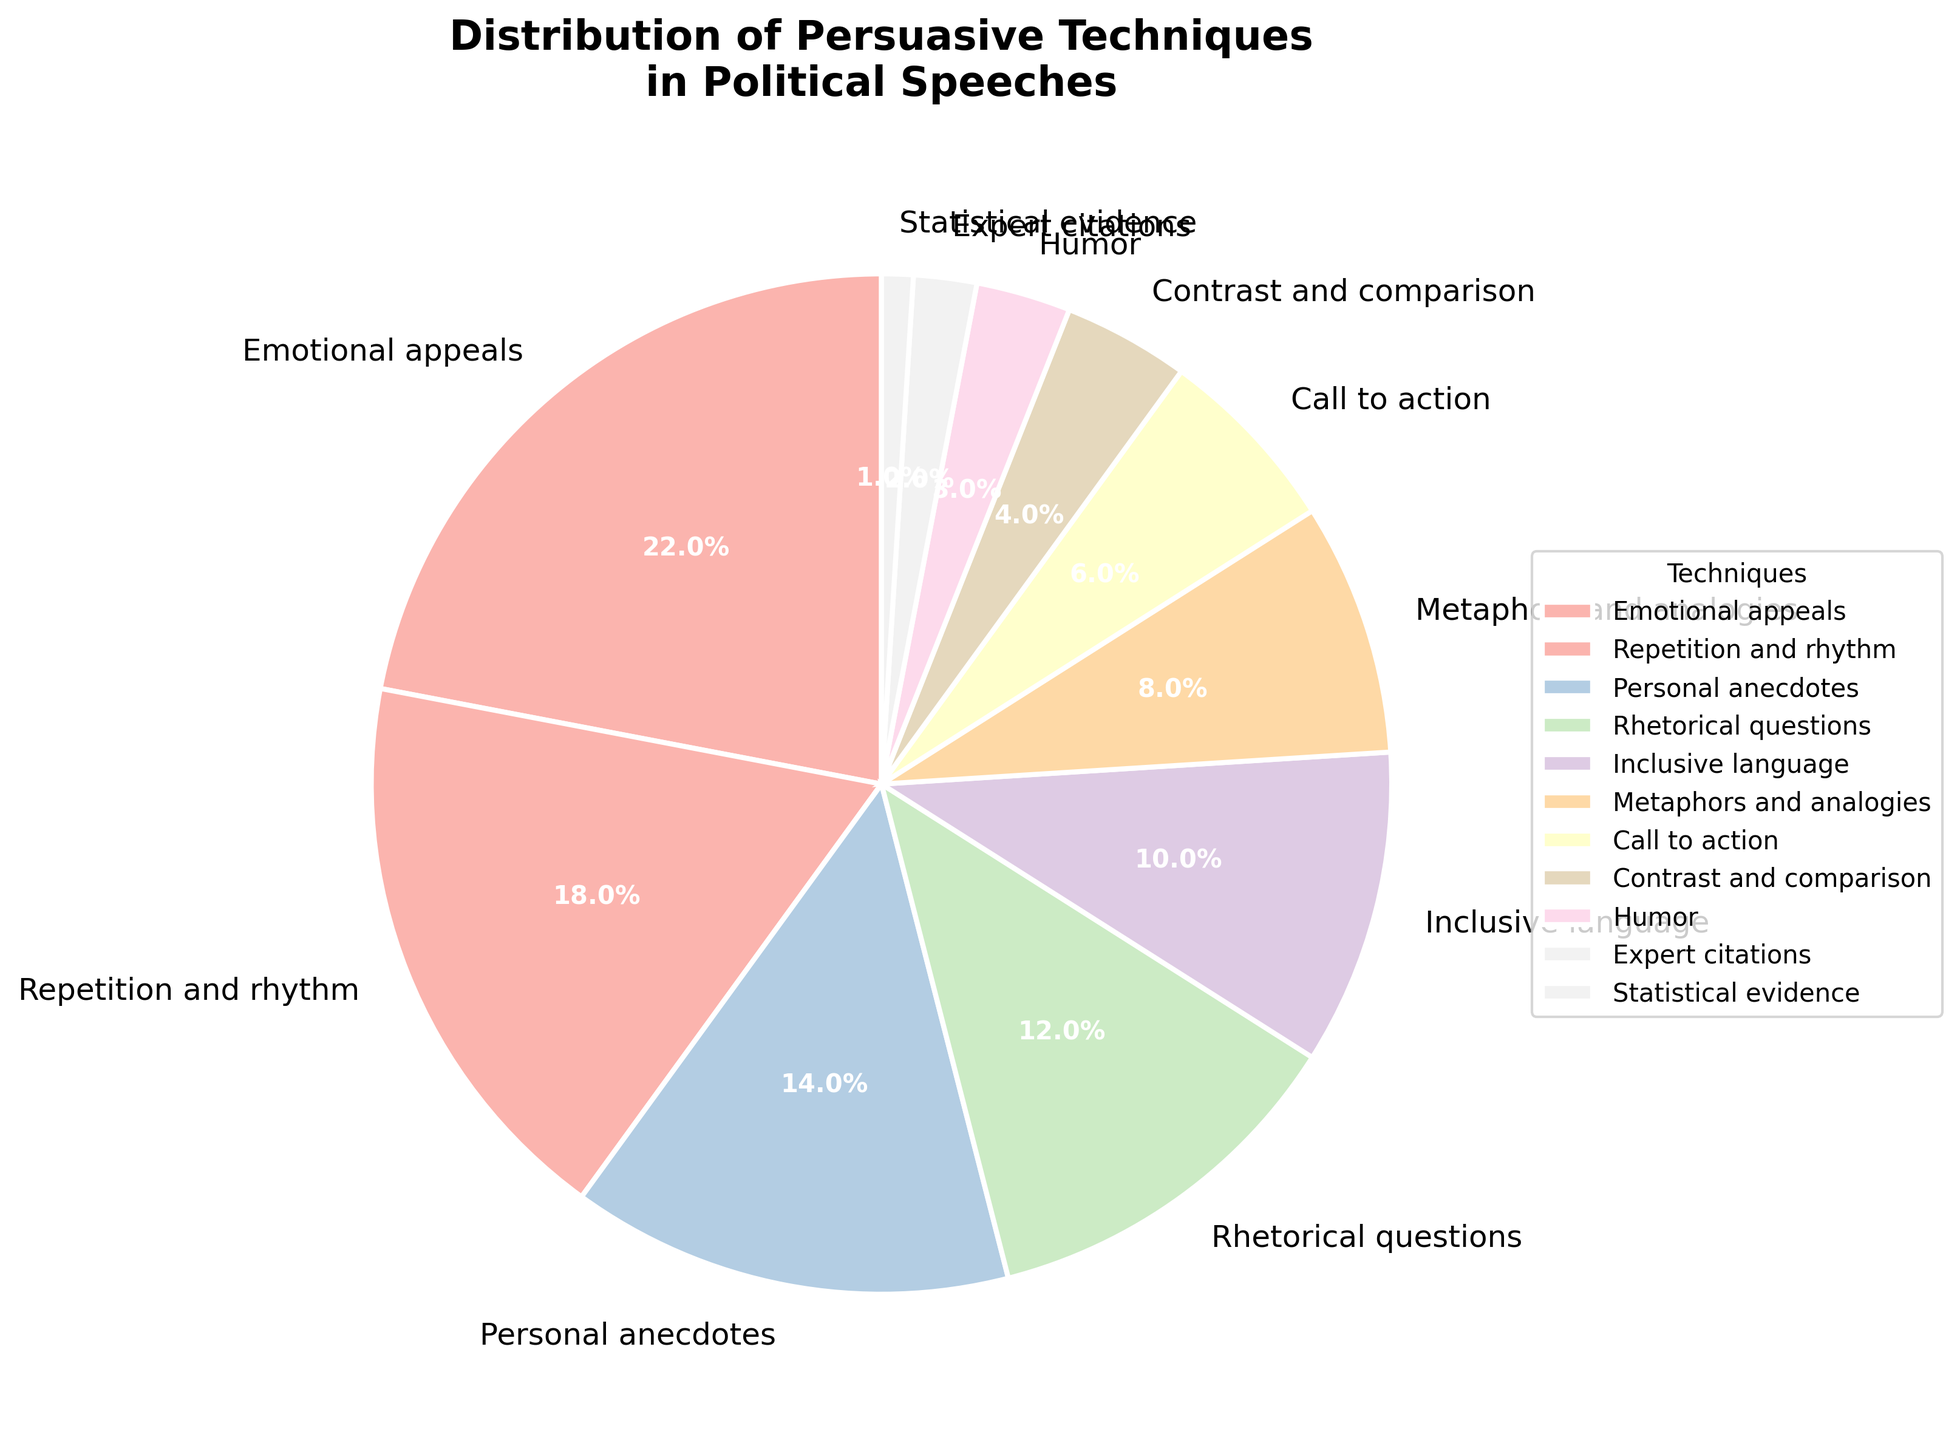Which technique is used the most in political speeches? The largest segment of the pie chart represents the technique that is used the most, which is depicted with the highest percentage. Emotional appeals have the largest segment with 22%.
Answer: Emotional appeals What is the combined percentage of Emotional appeals and Personal anecdotes? Add the percentages of both Emotional appeals and Personal anecdotes. Emotional appeals is 22% and Personal anecdotes is 14%, so 22% + 14% = 36%.
Answer: 36% Which technique contributes less to political speeches: Humor or Expert citations? Compare the percentages of Humor and Expert citations. Humor is at 3%, while Expert citations is at 2%. Therefore, Expert citations contribute less.
Answer: Expert citations What is the percentage difference between Rhetorical questions and Inclusive language? Subtract the percentage of Inclusive language from Rhetorical questions. Rhetorical questions is 12% and Inclusive language is 10%, so 12% - 10% = 2%.
Answer: 2% What is the total percentage of techniques that have a share of 5% or less each? Sum the percentages of techniques with 5% or less: Call to action (6%), Contrast and comparison (4%), Humor (3%), Expert citations (2%), and Statistical evidence (1%). But since Call to action is greater than 5%, we only sum Contrast and comparison, Humor, Expert citations, and Statistical evidence: 4% + 3% + 2% + 1% = 10%.
Answer: 10% Which techniques have a combined contribution that's nearly equal to the use of Emotional appeals? Identify techniques whose summed percentages equal, or come close to, the percentage of Emotional appeals (22%). The closest matches by summing repetitive combinations can be found as Repetition and rhythm (18%) and Call to action (6%), although Call to action itself is 6%, combining others might be required such as Inclusive language (10%) and Rhetorical questions (12%) = 22%.
Answer: Inclusive language + Rhetorical questions Of the techniques used, which two have the smallest percentage contributions? Identify the two smallest segments in the pie chart based on the percentages. The two smallest percentages are Statistical evidence (1%) and Expert citations (2%).
Answer: Statistical evidence and Expert citations What is the difference between the highest and the lowest percentages in the chart? Subtract the smallest percentage from the largest percentage. The highest percentage is Emotional appeals at 22%, and the smallest is Statistical evidence at 1%. So, 22% - 1% = 21%.
Answer: 21% 